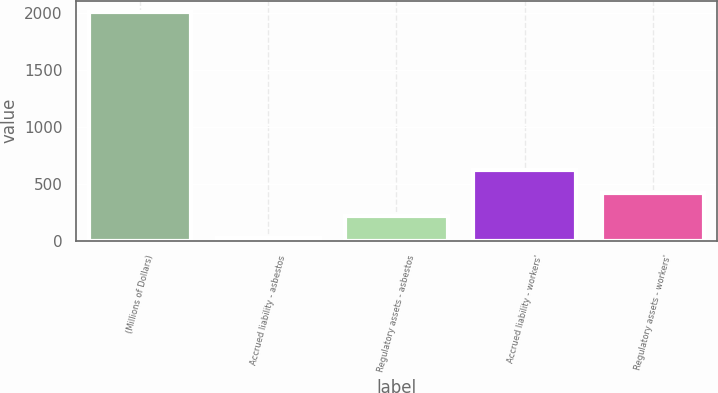Convert chart to OTSL. <chart><loc_0><loc_0><loc_500><loc_500><bar_chart><fcel>(Millions of Dollars)<fcel>Accrued liability - asbestos<fcel>Regulatory assets - asbestos<fcel>Accrued liability - workers'<fcel>Regulatory assets - workers'<nl><fcel>2005<fcel>25<fcel>223<fcel>619<fcel>421<nl></chart> 